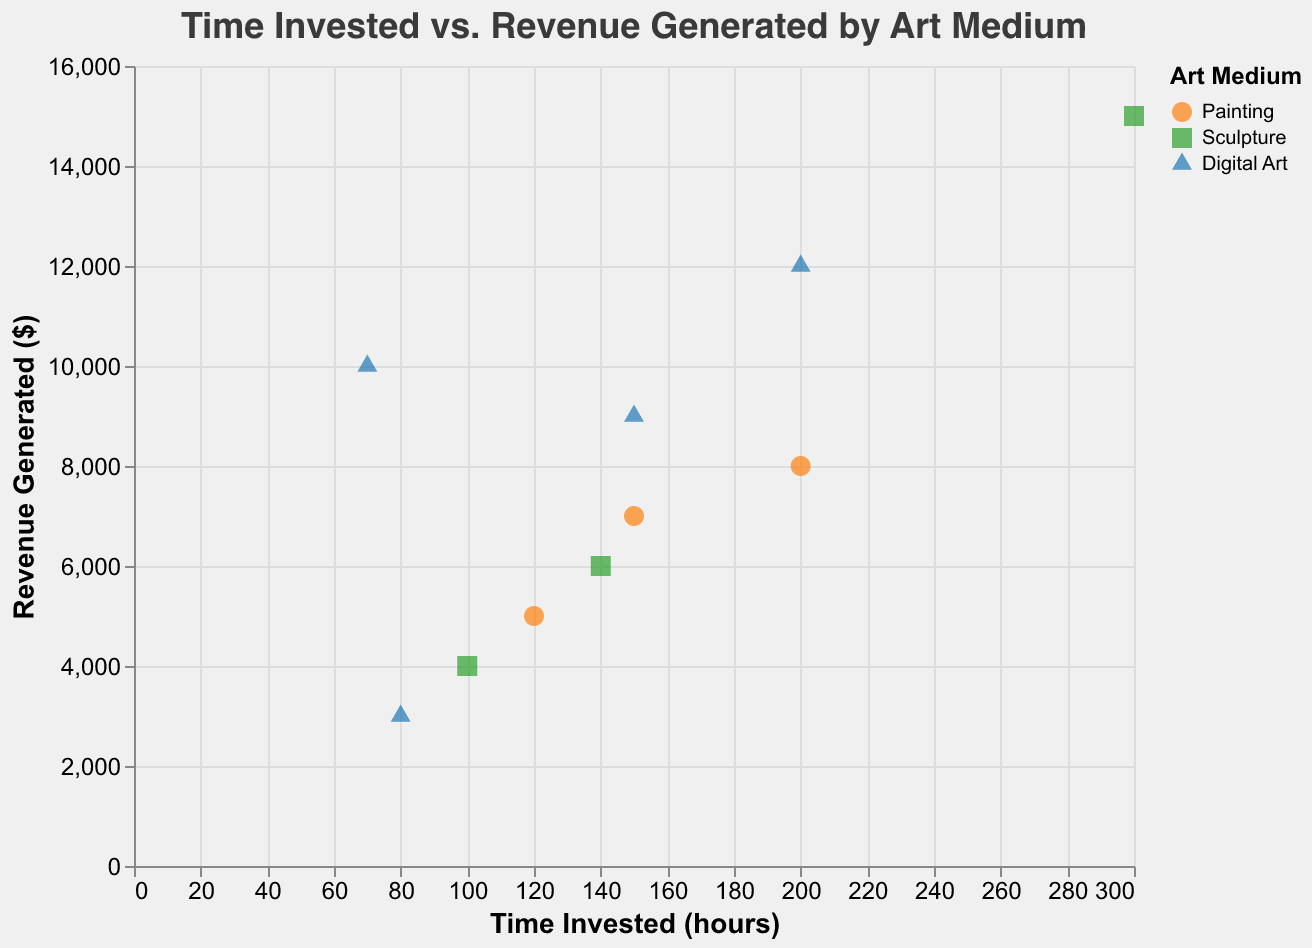What is the title of the figure? The title of the figure is displayed at the top of the plot, showing the main topic or focus of the data representation.
Answer: Time Invested vs. Revenue Generated by Art Medium What are the x-axis and y-axis representing? The labels on the x-axis and y-axis indicate what each axis represents; the x-axis shows "Time Invested (hours)" and the y-axis shows "Revenue Generated ($)".
Answer: Time Invested (hours) and Revenue Generated ($) How many art mediums are represented in the plot? The legend on the right side of the plot lists the different art mediums, identified by their colors and shapes.
Answer: 3 Which artist in the Digital Art medium generated the highest revenue? By looking at the points corresponding to Digital Art (blue triangles), find the one with the highest y-coordinate (Revenue Generated).
Answer: Creatify What is the average revenue generated by artists in the Painting medium? Add up the revenues of the artists in the Painting medium and divide by the number of artists in that group. ($5000 + $8000 + $7000) / 3 = $20000 / 3
Answer: $6667 Which art medium generally required the least amount of time invested to generate high revenue? Compare the range of time invested and revenue generated across different art mediums by analyzing the spread and positioning of the data points on the plot. Digital Art has artists like Banksy and Creatify, who invested relatively fewer hours but generated high revenue.
Answer: Digital Art What is the difference in revenue generated between the artist with the most time invested and the least time invested in the Sculpture medium? Identify the artists in the Sculpture medium (green squares) with the highest and lowest time invested, then subtract the lesser revenue from the greater one. Michelangelo: $15000 (300 hours), Hepworth: $4000 (100 hours). $15000 - $4000 = $11000.
Answer: $11000 Which artist invested 150 hours in their work and how much revenue did they generate? Look for the artists associated with the points found directly above 150 hours on the x-axis and check their revenue on the y-axis. There are two artists that invested 150 hours: Van Gogh (Painting) generated $7000 and Blender (Digital Art) generated $9000.
Answer: Van Gogh: $7000, Blender: $9000 